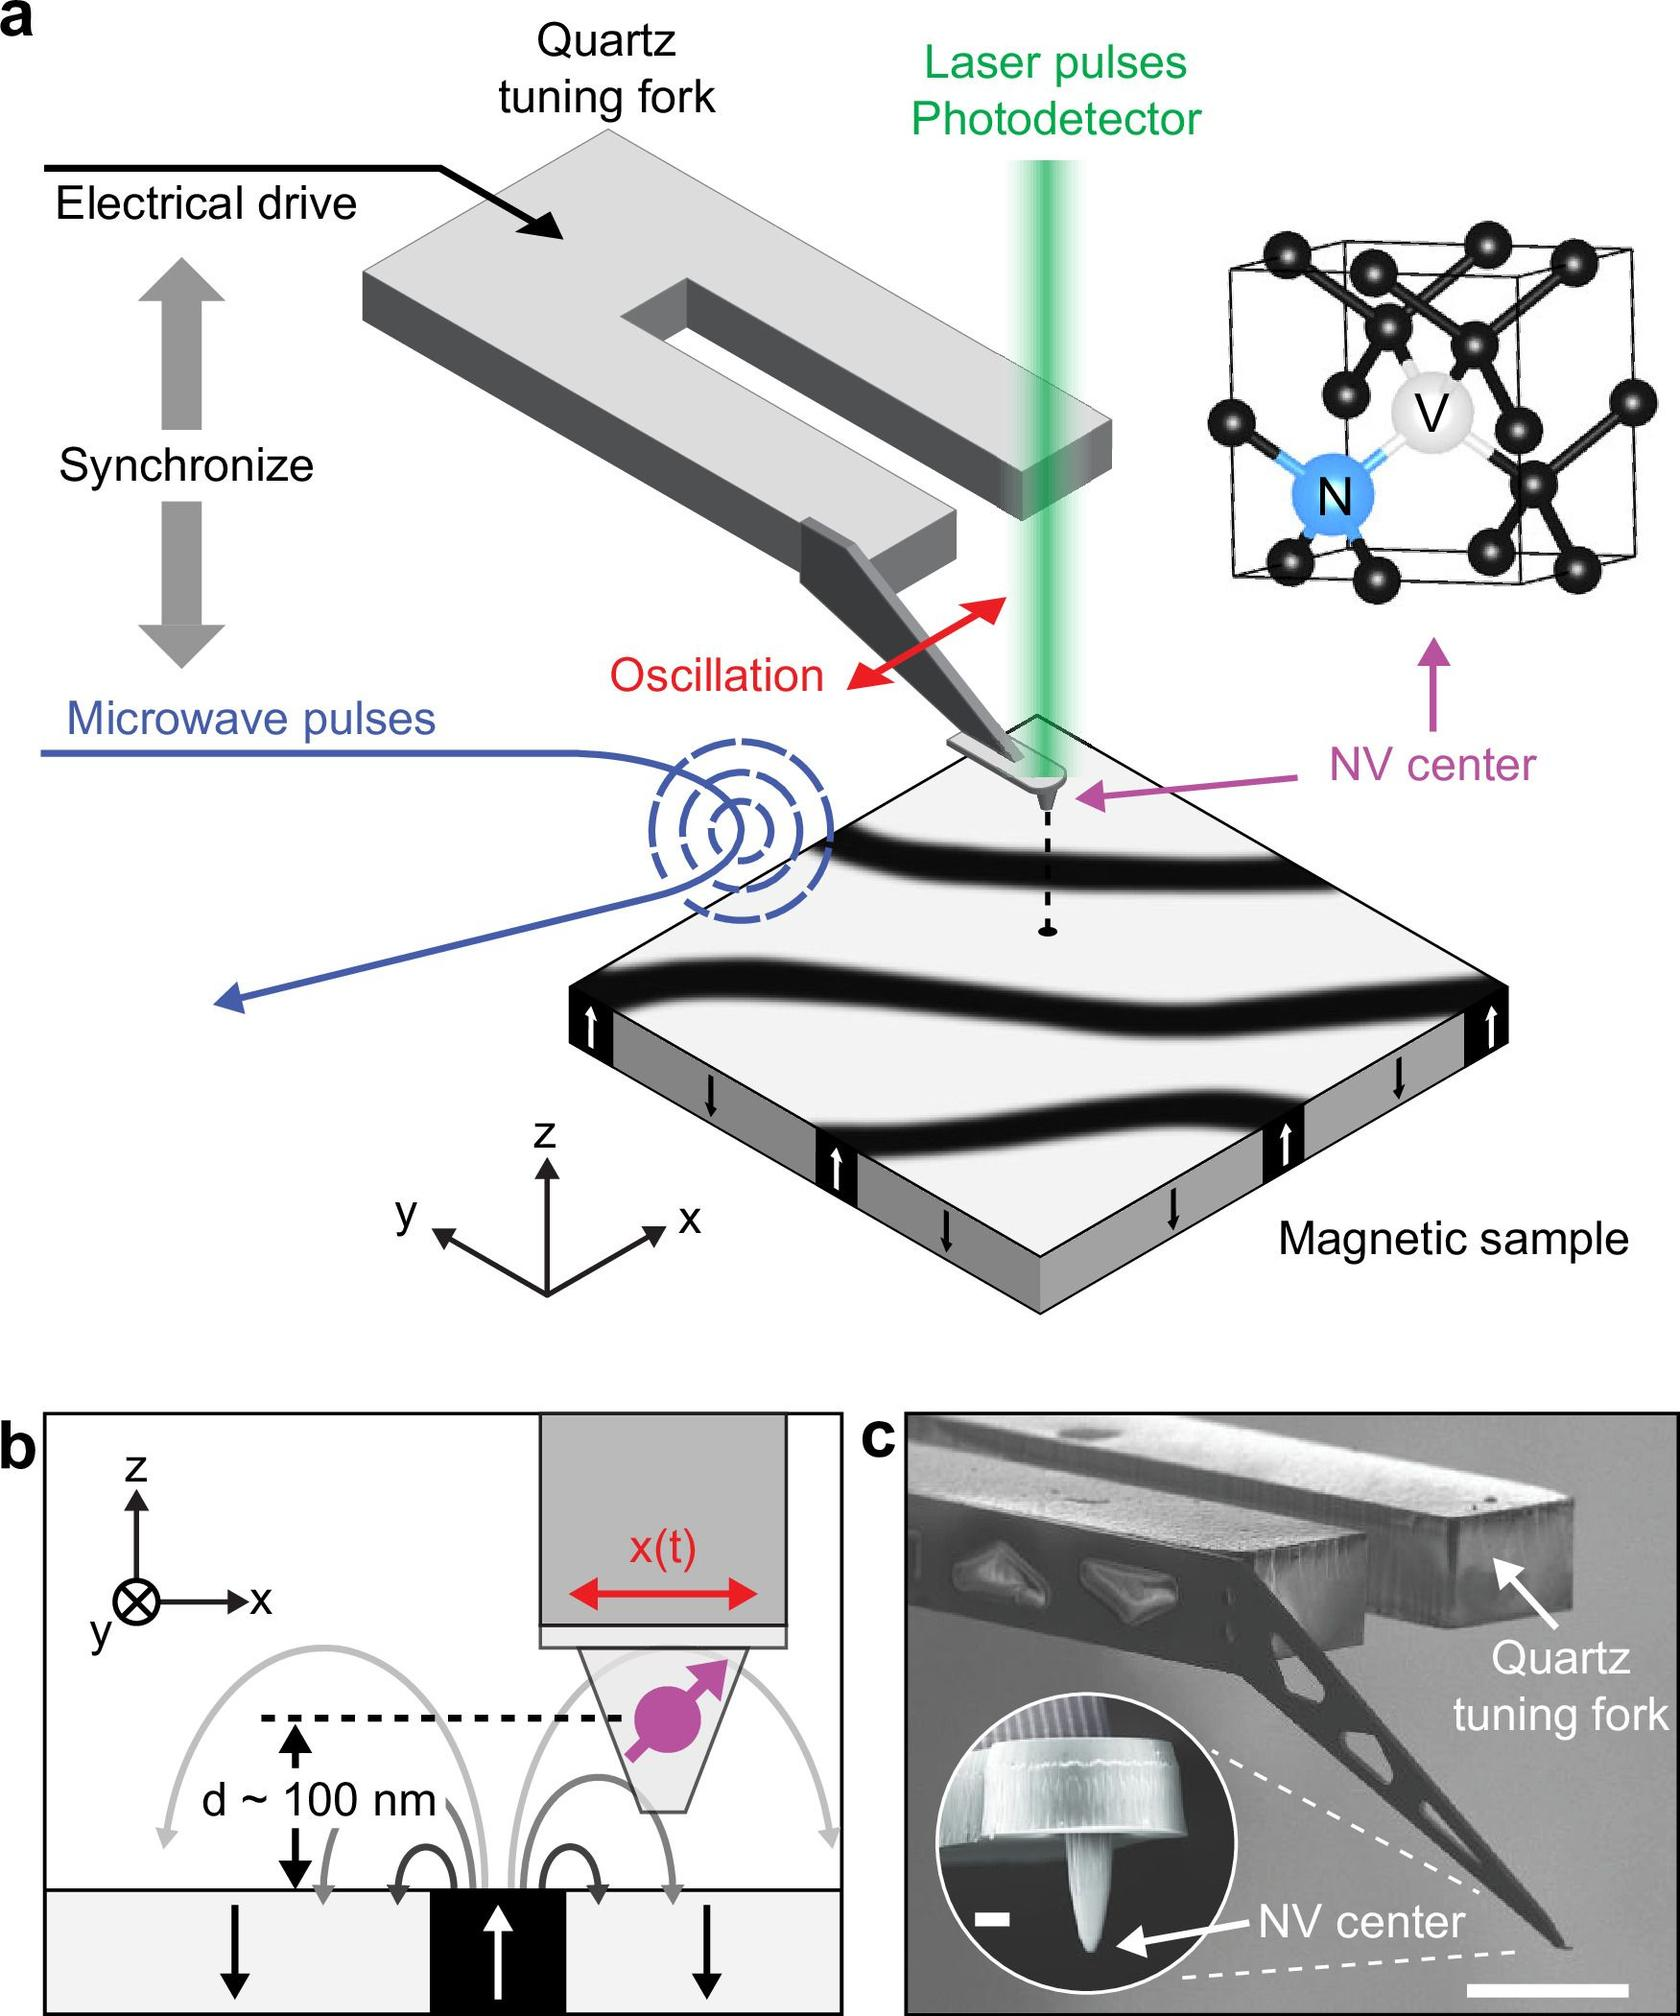What is the primary purpose of the quartz tuning fork in this experimental setup? A) To generate microwave pulses B) To detect laser pulses C) To provide mechanical oscillation synchronized with microwave pulses D) To serve as a magnetic sample The diagram labels the quartz tuning fork and indicates it is synchronized with microwave pulses that cause oscillation. This suggests its role is mechanical oscillation in sync with the pulses rather than generating or detecting them, or being the sample itself. Therefore, the correct answer is C. 